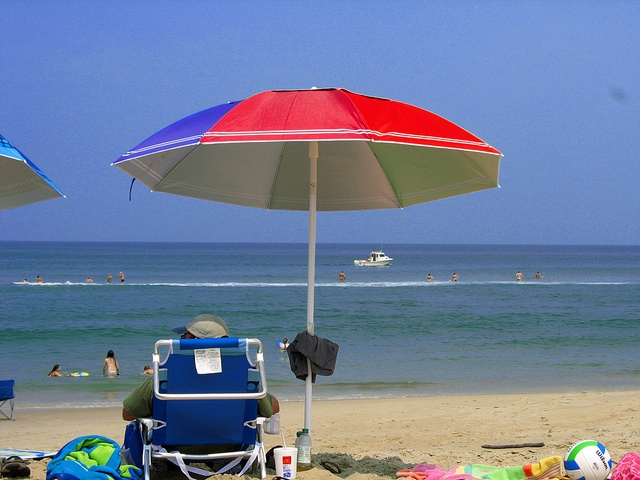Describe the objects in this image and their specific colors. I can see umbrella in blue, gray, red, and salmon tones, chair in blue, navy, lightgray, black, and darkgray tones, umbrella in blue, gray, and lightblue tones, sports ball in blue, white, darkgray, lime, and tan tones, and people in blue, gray, darkgray, and black tones in this image. 